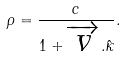Convert formula to latex. <formula><loc_0><loc_0><loc_500><loc_500>\rho = \frac { c } { 1 + \overrightarrow { v } . \hat { \kappa } } .</formula> 